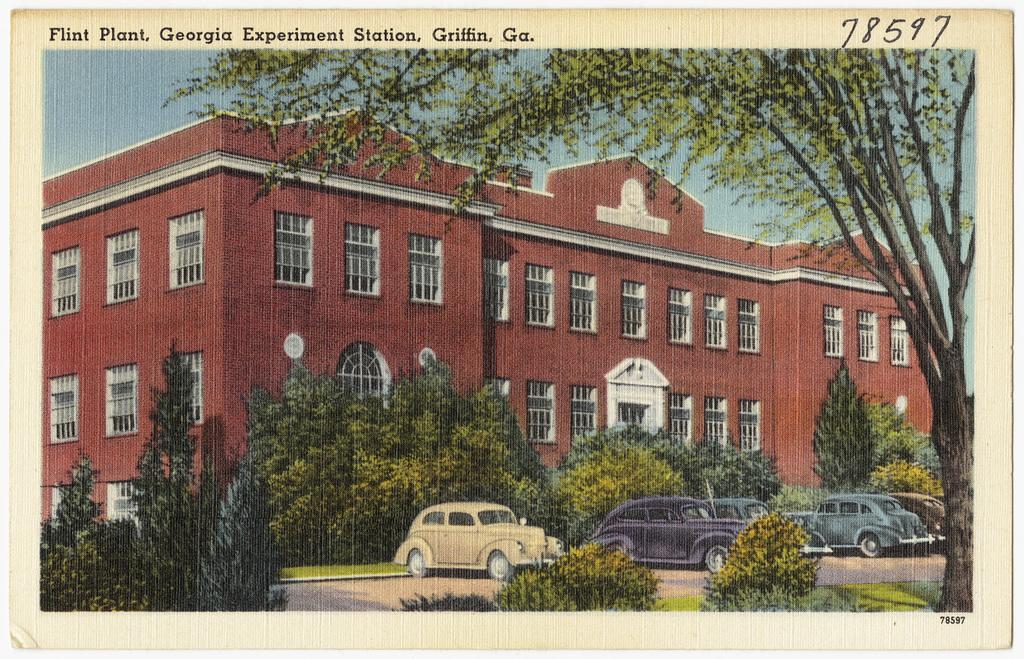Describe this image in one or two sentences. In this image there is a painting. There are few cars on the road. Behind it there is grassland having few trees. Background there is a building. Right side there is a tree. Bottom of the image there are few plants. Left top there is sky. Top of the image there is some text. 